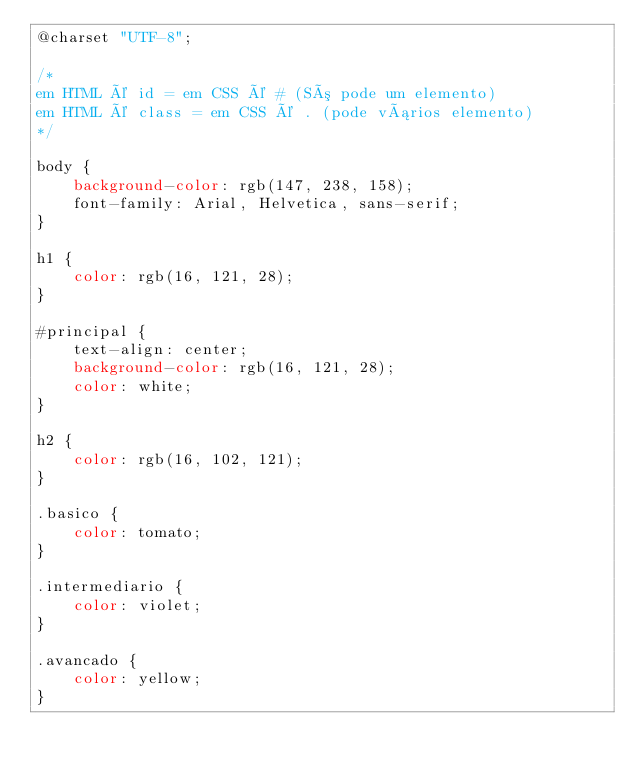<code> <loc_0><loc_0><loc_500><loc_500><_CSS_>@charset "UTF-8";

/*
em HTML é id = em CSS é # (Só pode um elemento)
em HTML é class = em CSS é . (pode vários elemento)
*/

body {
    background-color: rgb(147, 238, 158);
    font-family: Arial, Helvetica, sans-serif;
}

h1 {
    color: rgb(16, 121, 28);
}

#principal {
    text-align: center;
    background-color: rgb(16, 121, 28);
    color: white;
}

h2 {
    color: rgb(16, 102, 121);
}

.basico {
    color: tomato;
}

.intermediario {
    color: violet;
}

.avancado {
    color: yellow;
}</code> 